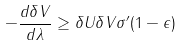<formula> <loc_0><loc_0><loc_500><loc_500>- \frac { d \delta V } { d \lambda } \geq \delta U \delta V \sigma ^ { \prime } ( 1 - \epsilon )</formula> 